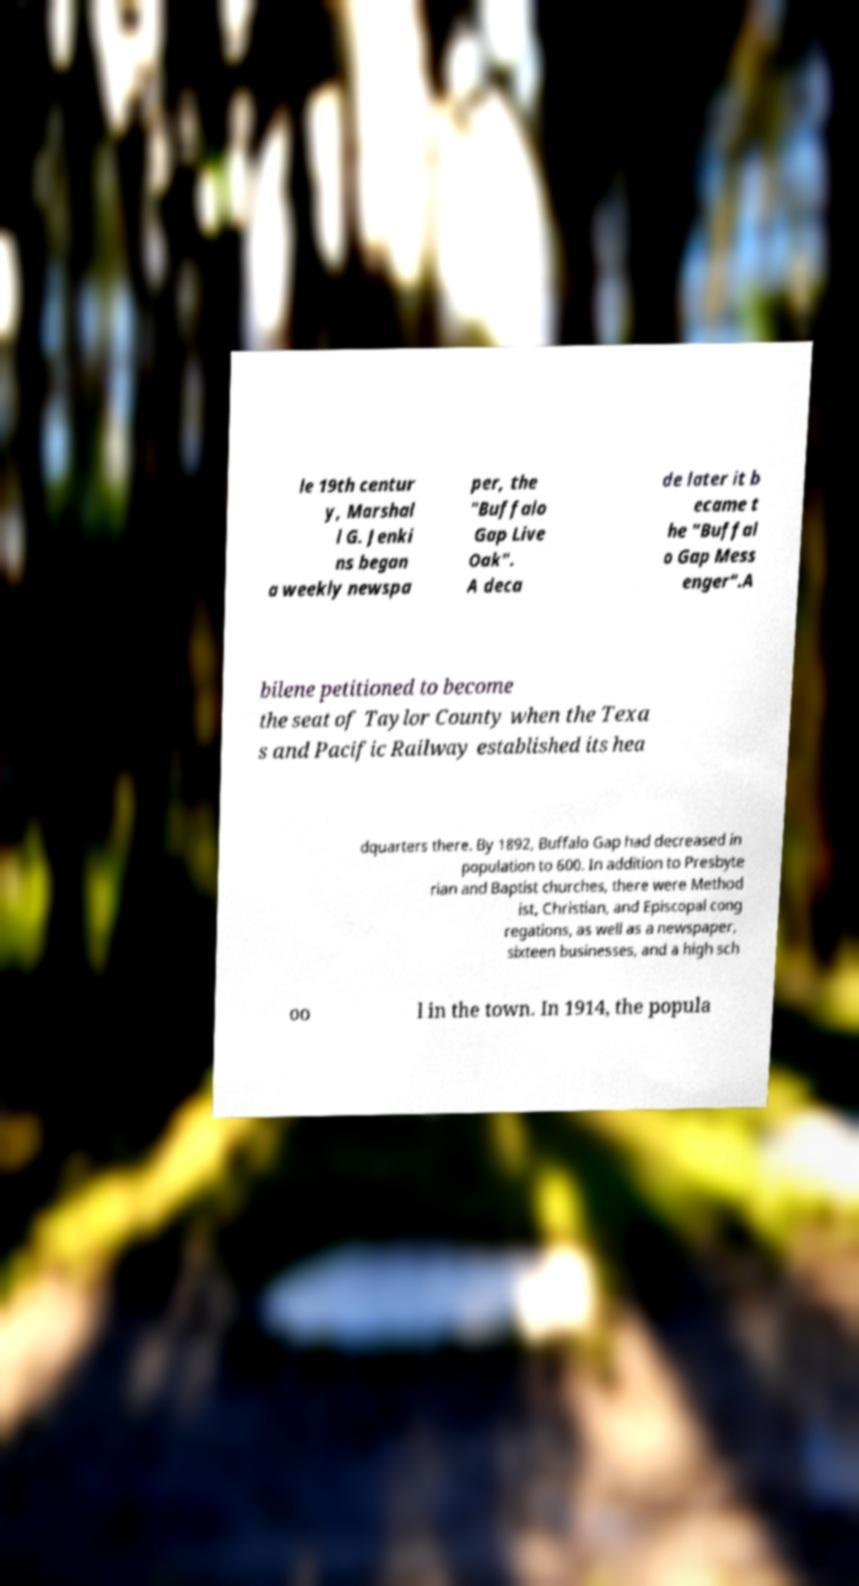What messages or text are displayed in this image? I need them in a readable, typed format. le 19th centur y, Marshal l G. Jenki ns began a weekly newspa per, the "Buffalo Gap Live Oak". A deca de later it b ecame t he "Buffal o Gap Mess enger".A bilene petitioned to become the seat of Taylor County when the Texa s and Pacific Railway established its hea dquarters there. By 1892, Buffalo Gap had decreased in population to 600. In addition to Presbyte rian and Baptist churches, there were Method ist, Christian, and Episcopal cong regations, as well as a newspaper, sixteen businesses, and a high sch oo l in the town. In 1914, the popula 